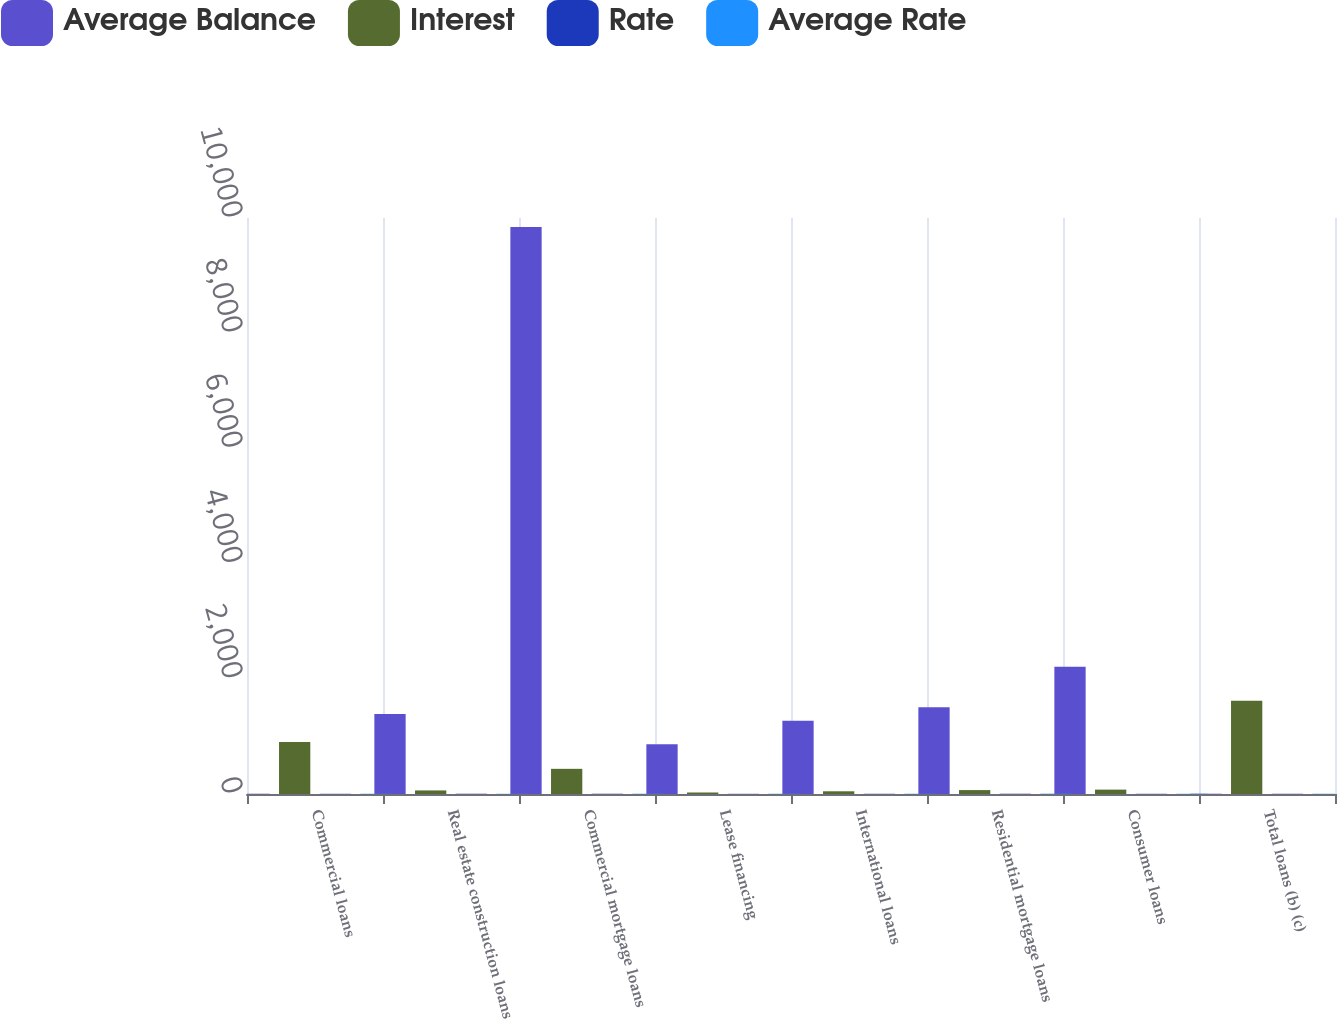<chart> <loc_0><loc_0><loc_500><loc_500><stacked_bar_chart><ecel><fcel>Commercial loans<fcel>Real estate construction loans<fcel>Commercial mortgage loans<fcel>Lease financing<fcel>International loans<fcel>Residential mortgage loans<fcel>Consumer loans<fcel>Total loans (b) (c)<nl><fcel>Average Balance<fcel>4.925<fcel>1390<fcel>9842<fcel>864<fcel>1272<fcel>1505<fcel>2209<fcel>4.925<nl><fcel>Interest<fcel>903<fcel>62<fcel>437<fcel>26<fcel>47<fcel>68<fcel>76<fcel>1619<nl><fcel>Rate<fcel>3.44<fcel>4.44<fcel>4.44<fcel>3.01<fcel>3.73<fcel>4.55<fcel>3.42<fcel>3.74<nl><fcel>Average Rate<fcel>3.89<fcel>3.17<fcel>4.1<fcel>3.88<fcel>3.94<fcel>5.3<fcel>3.54<fcel>4<nl></chart> 